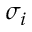<formula> <loc_0><loc_0><loc_500><loc_500>\sigma _ { i }</formula> 